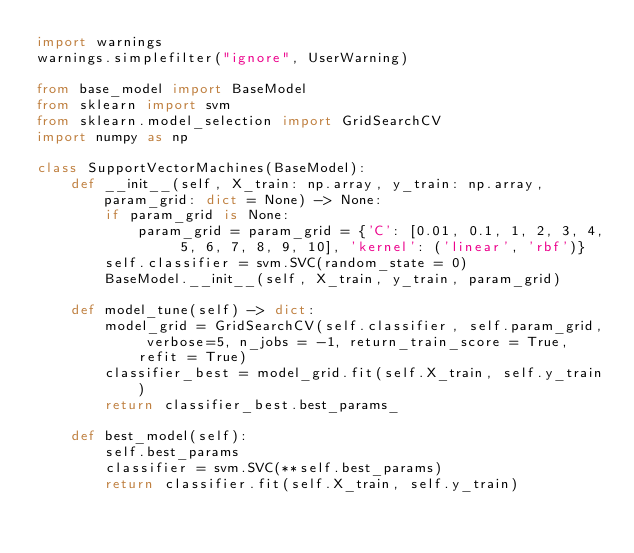Convert code to text. <code><loc_0><loc_0><loc_500><loc_500><_Python_>import warnings
warnings.simplefilter("ignore", UserWarning)

from base_model import BaseModel
from sklearn import svm
from sklearn.model_selection import GridSearchCV
import numpy as np

class SupportVectorMachines(BaseModel):
    def __init__(self, X_train: np.array, y_train: np.array, param_grid: dict = None) -> None:
        if param_grid is None:
            param_grid = param_grid = {'C': [0.01, 0.1, 1, 2, 3, 4, 5, 6, 7, 8, 9, 10], 'kernel': ('linear', 'rbf')}
        self.classifier = svm.SVC(random_state = 0)
        BaseModel.__init__(self, X_train, y_train, param_grid)
    
    def model_tune(self) -> dict:
        model_grid = GridSearchCV(self.classifier, self.param_grid, verbose=5, n_jobs = -1, return_train_score = True, refit = True)
        classifier_best = model_grid.fit(self.X_train, self.y_train)
        return classifier_best.best_params_
    
    def best_model(self):
        self.best_params
        classifier = svm.SVC(**self.best_params)
        return classifier.fit(self.X_train, self.y_train)</code> 